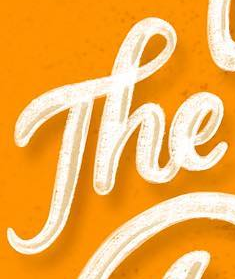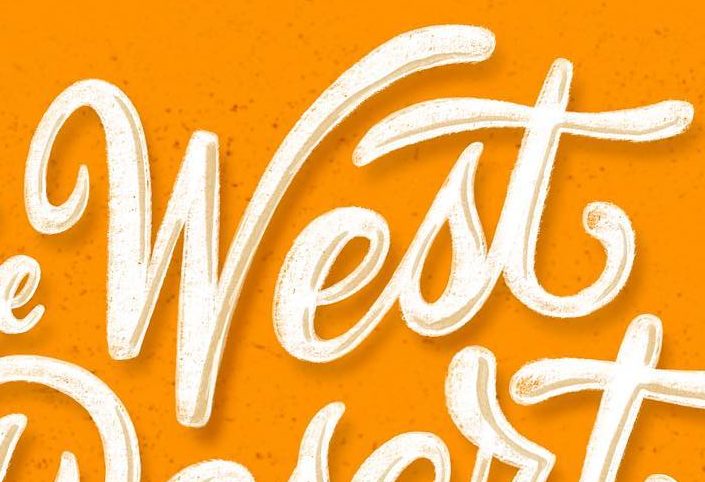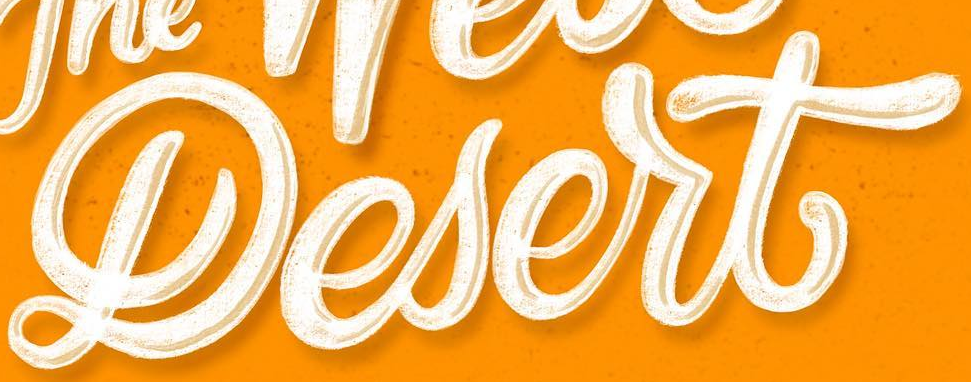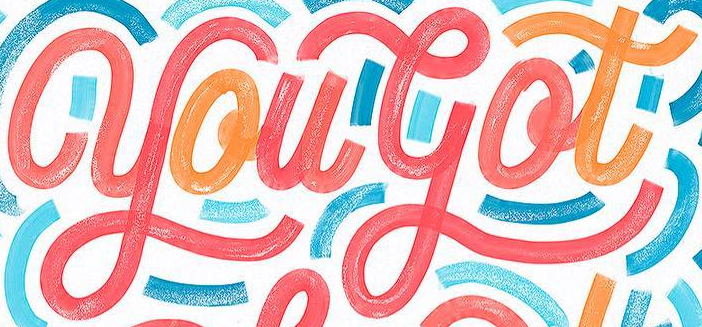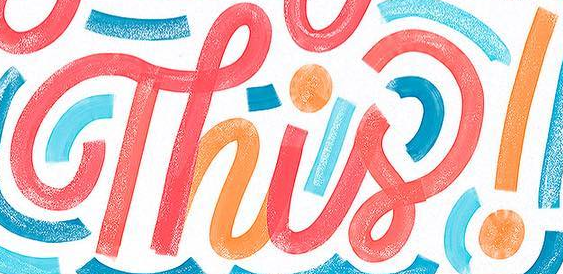Transcribe the words shown in these images in order, separated by a semicolon. The; West; Lesert; yougot; Thisǃ 